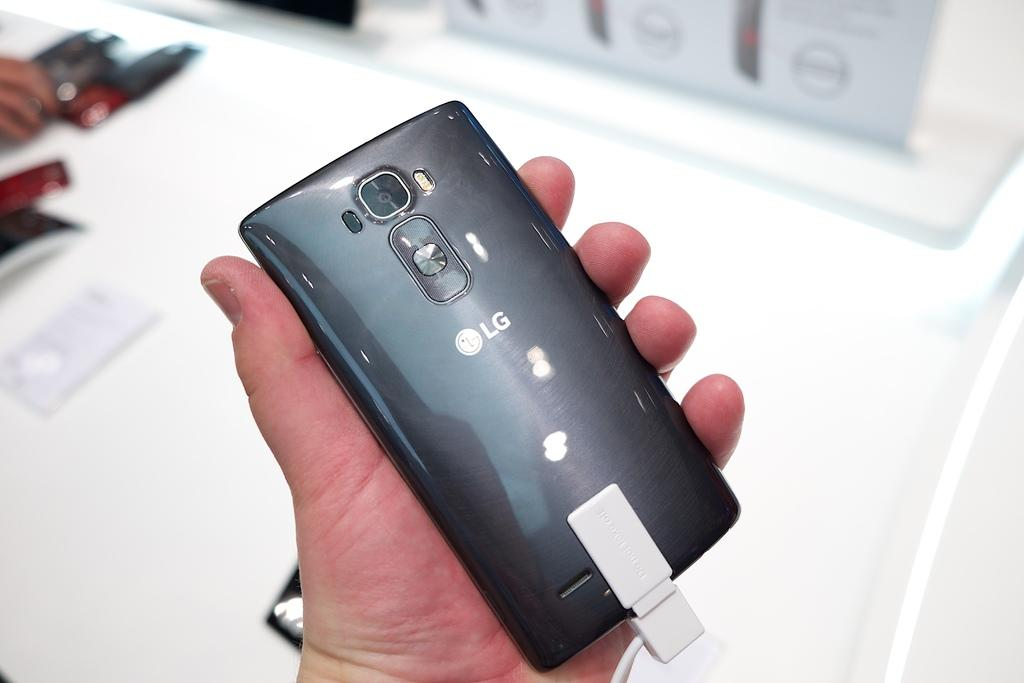<image>
Give a short and clear explanation of the subsequent image. a phone with LG written on the back of it 